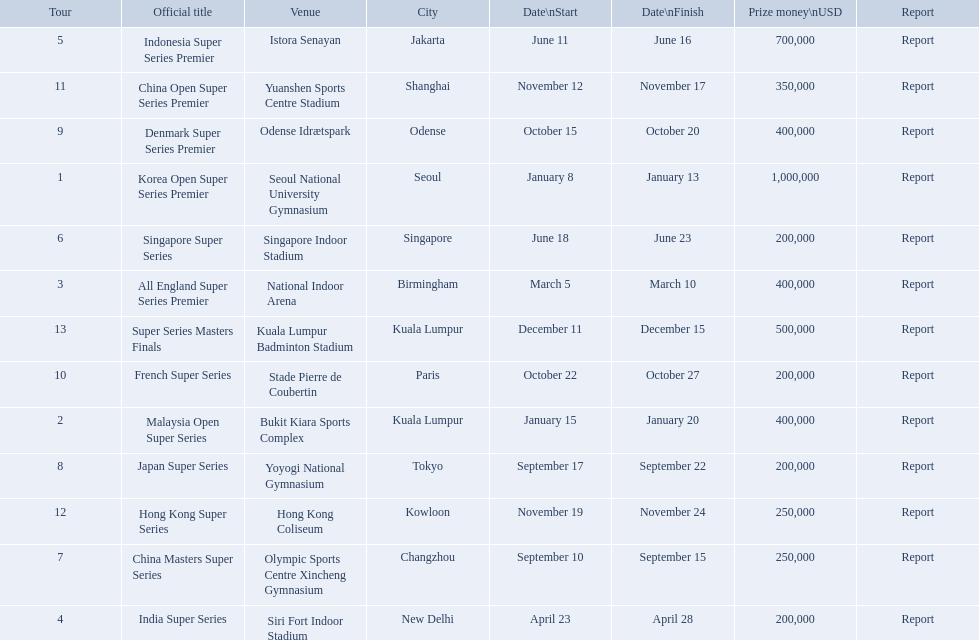What are all the titles? Korea Open Super Series Premier, Malaysia Open Super Series, All England Super Series Premier, India Super Series, Indonesia Super Series Premier, Singapore Super Series, China Masters Super Series, Japan Super Series, Denmark Super Series Premier, French Super Series, China Open Super Series Premier, Hong Kong Super Series, Super Series Masters Finals. When did they take place? January 8, January 15, March 5, April 23, June 11, June 18, September 10, September 17, October 15, October 22, November 12, November 19, December 11. Which title took place in december? Super Series Masters Finals. 